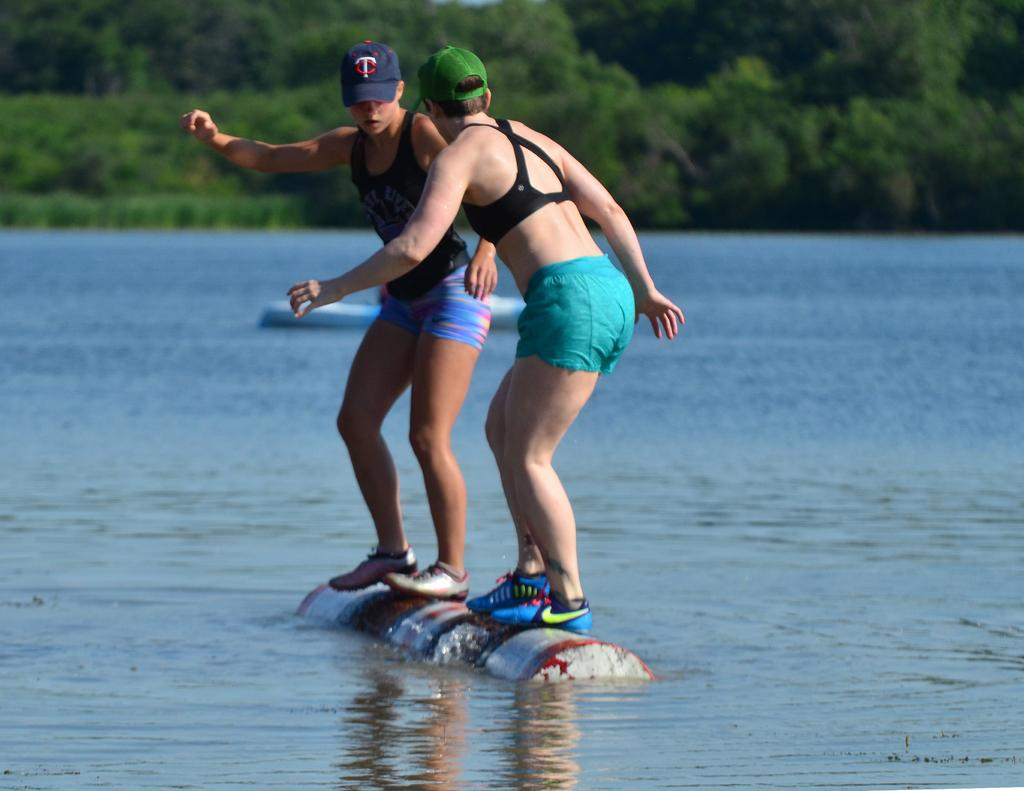What are the two persons in the image doing? The two persons are standing in the water. What colors are the caps worn by the persons? One person is wearing a green color cap, and the other person is wearing a blue color cap. What can be seen in the background of the image? There are trees visible in the background of the image. What type of voice can be heard coming from the scene in the image? There is no sound or voice present in the image, as it is a still photograph. 